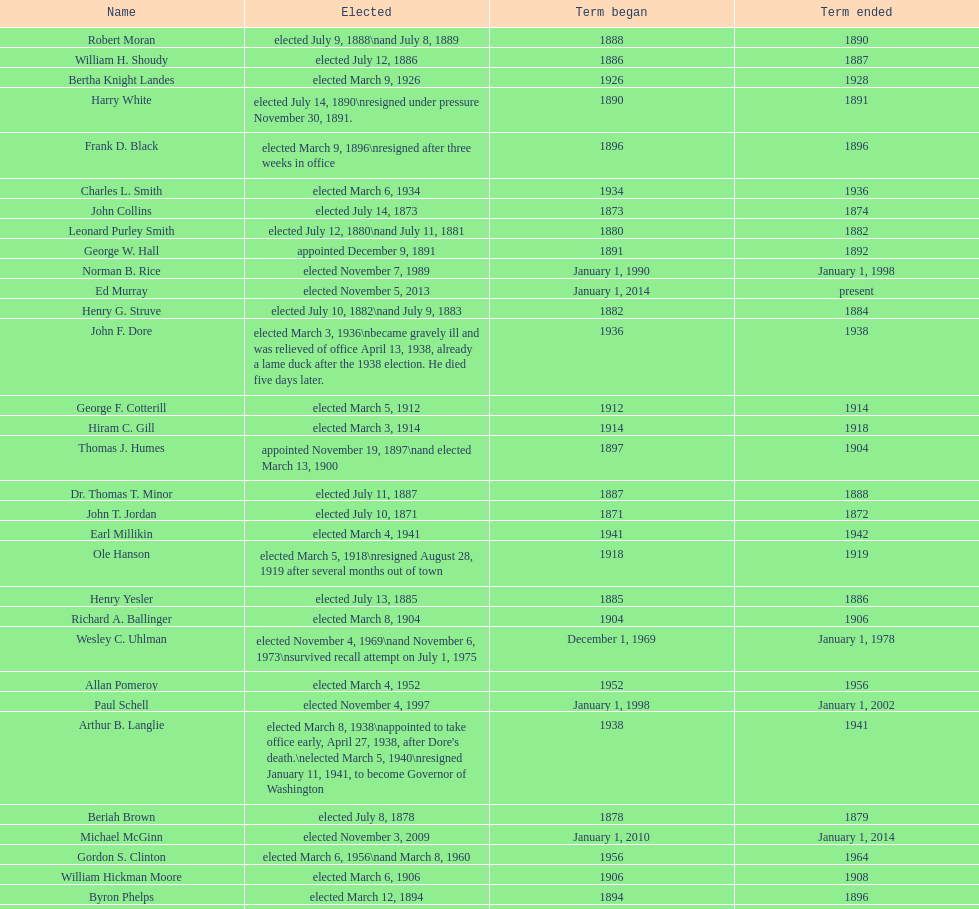Parse the full table. {'header': ['Name', 'Elected', 'Term began', 'Term ended'], 'rows': [['Robert Moran', 'elected July 9, 1888\\nand July 8, 1889', '1888', '1890'], ['William H. Shoudy', 'elected July 12, 1886', '1886', '1887'], ['Bertha Knight Landes', 'elected March 9, 1926', '1926', '1928'], ['Harry White', 'elected July 14, 1890\\nresigned under pressure November 30, 1891.', '1890', '1891'], ['Frank D. Black', 'elected March 9, 1896\\nresigned after three weeks in office', '1896', '1896'], ['Charles L. Smith', 'elected March 6, 1934', '1934', '1936'], ['John Collins', 'elected July 14, 1873', '1873', '1874'], ['Leonard Purley Smith', 'elected July 12, 1880\\nand July 11, 1881', '1880', '1882'], ['George W. Hall', 'appointed December 9, 1891', '1891', '1892'], ['Norman B. Rice', 'elected November 7, 1989', 'January 1, 1990', 'January 1, 1998'], ['Ed Murray', 'elected November 5, 2013', 'January 1, 2014', 'present'], ['Henry G. Struve', 'elected July 10, 1882\\nand July 9, 1883', '1882', '1884'], ['John F. Dore', 'elected March 3, 1936\\nbecame gravely ill and was relieved of office April 13, 1938, already a lame duck after the 1938 election. He died five days later.', '1936', '1938'], ['George F. Cotterill', 'elected March 5, 1912', '1912', '1914'], ['Hiram C. Gill', 'elected March 3, 1914', '1914', '1918'], ['Thomas J. Humes', 'appointed November 19, 1897\\nand elected March 13, 1900', '1897', '1904'], ['Dr. Thomas T. Minor', 'elected July 11, 1887', '1887', '1888'], ['John T. Jordan', 'elected July 10, 1871', '1871', '1872'], ['Earl Millikin', 'elected March 4, 1941', '1941', '1942'], ['Ole Hanson', 'elected March 5, 1918\\nresigned August 28, 1919 after several months out of town', '1918', '1919'], ['Henry Yesler', 'elected July 13, 1885', '1885', '1886'], ['Richard A. Ballinger', 'elected March 8, 1904', '1904', '1906'], ['Wesley C. Uhlman', 'elected November 4, 1969\\nand November 6, 1973\\nsurvived recall attempt on July 1, 1975', 'December 1, 1969', 'January 1, 1978'], ['Allan Pomeroy', 'elected March 4, 1952', '1952', '1956'], ['Paul Schell', 'elected November 4, 1997', 'January 1, 1998', 'January 1, 2002'], ['Arthur B. Langlie', "elected March 8, 1938\\nappointed to take office early, April 27, 1938, after Dore's death.\\nelected March 5, 1940\\nresigned January 11, 1941, to become Governor of Washington", '1938', '1941'], ['Beriah Brown', 'elected July 8, 1878', '1878', '1879'], ['Michael McGinn', 'elected November 3, 2009', 'January 1, 2010', 'January 1, 2014'], ['Gordon S. Clinton', 'elected March 6, 1956\\nand March 8, 1960', '1956', '1964'], ['William Hickman Moore', 'elected March 6, 1906', '1906', '1908'], ['Byron Phelps', 'elected March 12, 1894', '1894', '1896'], ['Henry Yesler', 'elected July 13, 1874', '1874', '1875'], ['Bailey Gatzert', 'elected August 2, 1875', '1875', '1876'], ['Floyd C. Miller', 'appointed March 23, 1969', '1969', '1969'], ['Moses R. Maddocks', 'Elected', '1873', '1873'], ['Robert H. Harlin', 'appointed July 14, 1931', '1931', '1932'], ['John Leary', 'elected July 14, 1884', '1884', '1885'], ['John T. Jordan', 'appointed', '1873', '1873'], ['Edwin J. Brown', 'elected May 2, 1922\\nand March 4, 1924', '1922', '1926'], ['C. B. Fitzgerald', 'appointed August 28, 1919', '1919', '1920'], ['Henry A. Atkins', 'appointed December 2, 1869\\nelected July 11, 1870', '1869', '1871'], ['George W. Dilling', 'appointed February 10, 1911[citation needed]', '1912', ''], ['Orange Jacobs', 'elected July 14, 1879', '1879', '1880'], ['Frank E. Edwards', 'elected March 6, 1928\\nand March 4, 1930\\nrecalled July 13, 1931', '1928', '1931'], ['Hugh M. Caldwell', 'elected March 2, 1920', '1920', '1922'], ['Gregory J. Nickels', 'elected November 6, 2001\\nand November 8, 2005', 'January 1, 2002', 'January 1, 2010'], ['Hiram C. Gill', 'elected March 8, 1910\\nrecalled February 9, 1911', '1910', '1911'], ['John F. Dore', 'elected March 8, 1932', '1932', '1934'], ["James d'Orma Braman", 'elected March 10, 1964\\nresigned March 23, 1969, to accept an appointment as an Assistant Secretary in the Department of Transportation in the Nixon administration.', '1964', '1969'], ['Gideon A. Weed', 'elected July 10, 1876\\nand July 9, 1877', '1876', '1878'], ['Charles Royer', 'elected November 8, 1977, November 3, 1981, and November 5, 1985', 'January 1, 1978', 'January 1, 1990'], ['James T. Ronald', 'elected March 8, 1892', '1892', '1894'], ['William F. Devin', 'elected March 3, 1942, March 7, 1944, March 5, 1946, and March 2, 1948', '1942', '1952'], ['W. D. Wood', 'appointed April 6, 1896\\nresigned July 1897', '1896', '1897'], ['John E. Carroll', 'appointed January 27, 1941', '1941', '1941'], ['John F. Miller', 'elected March 3, 1908', '1908', '1910'], ['Corliss P. Stone', 'elected July 8, 1872\\nabandoned office: left for San Francisco February 23, 1873 after allegedly embezzling $15,000', '1872', '1873']]} Which mayor seattle, washington resigned after only three weeks in office in 1896? Frank D. Black. 